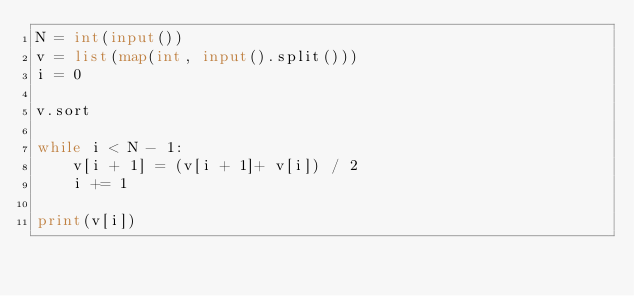Convert code to text. <code><loc_0><loc_0><loc_500><loc_500><_Python_>N = int(input())
v = list(map(int, input().split()))
i = 0

v.sort

while i < N - 1:
    v[i + 1] = (v[i + 1]+ v[i]) / 2
    i += 1
    
print(v[i])</code> 